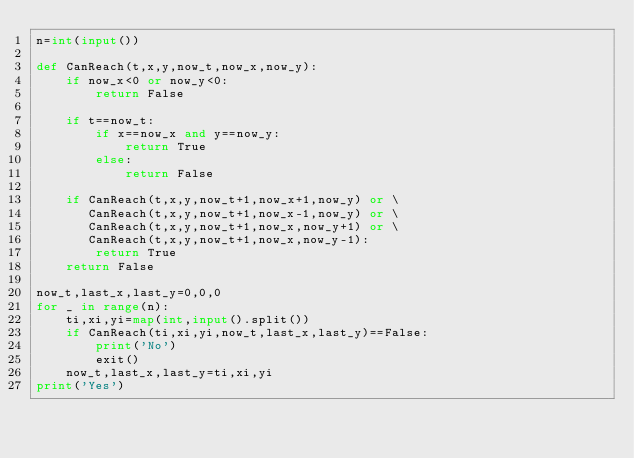<code> <loc_0><loc_0><loc_500><loc_500><_Python_>n=int(input())

def CanReach(t,x,y,now_t,now_x,now_y):
    if now_x<0 or now_y<0:
        return False

    if t==now_t:
        if x==now_x and y==now_y:
            return True
        else:
            return False

    if CanReach(t,x,y,now_t+1,now_x+1,now_y) or \
       CanReach(t,x,y,now_t+1,now_x-1,now_y) or \
       CanReach(t,x,y,now_t+1,now_x,now_y+1) or \
       CanReach(t,x,y,now_t+1,now_x,now_y-1):
        return True
    return False

now_t,last_x,last_y=0,0,0
for _ in range(n):
    ti,xi,yi=map(int,input().split())
    if CanReach(ti,xi,yi,now_t,last_x,last_y)==False:
        print('No')
        exit()
    now_t,last_x,last_y=ti,xi,yi
print('Yes')</code> 